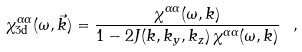Convert formula to latex. <formula><loc_0><loc_0><loc_500><loc_500>\chi _ { \text {3d} } ^ { \alpha \alpha } ( \omega , \vec { k } ) = \frac { \chi ^ { \alpha \alpha } ( \omega , k ) } { 1 - 2 J ( k , k _ { y } , k _ { z } ) \, \chi ^ { \alpha \alpha } ( \omega , k ) } \ ,</formula> 